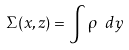<formula> <loc_0><loc_0><loc_500><loc_500>\Sigma ( x , z ) = \int \rho \ d y</formula> 